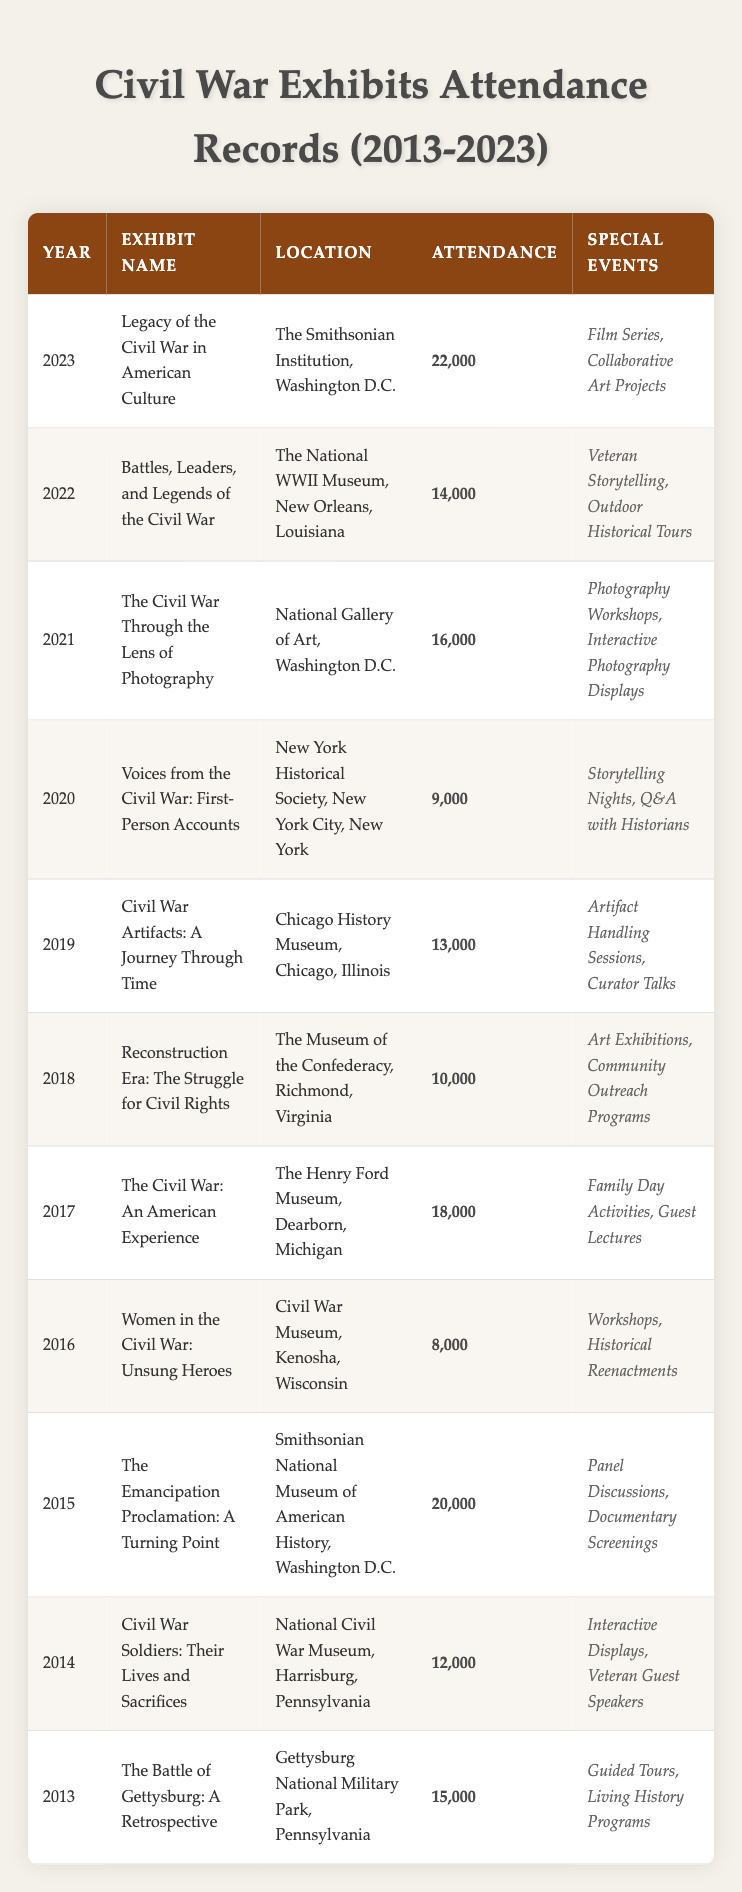What was the highest attendance recorded during the exhibits? The highest attendance can be found by looking through the attendance column in the table. The figure 22,000 in 2023 for the exhibit "Legacy of the Civil War in American Culture" is the highest.
Answer: 22,000 Which year had the minimum attendance for a Civil War exhibit? By scanning the attendance values in the table, we see that 8,000 in 2016 for the exhibit "Women in the Civil War: Unsung Heroes" is the lowest attendance recorded.
Answer: 2016 How many exhibits had an attendance of over 15,000? We can count the number of rows in the table where the attendance value exceeds 15,000. The attendance values that meet this criterion are 22,000, 20,000, 18,000, and 16,000, giving a total of four exhibits with beyond 15,000 attendance.
Answer: 4 Did the "Civil War Soldiers: Their Lives and Sacrifices" exhibit have more attendees than the "Reconstruction Era: The Struggle for Civil Rights" exhibit? The attendance for "Civil War Soldiers: Their Lives and Sacrifices" is 12,000, while for "Reconstruction Era: The Struggle for Civil Rights," it is 10,000. Since 12,000 is greater than 10,000, the statement is true.
Answer: Yes What was the total attendance for the exhibits from 2013 to 2023? To calculate the total, we need to add all attendance values: 15,000 + 12,000 + 20,000 + 8,000 + 18,000 + 10,000 + 13,000 + 9,000 + 16,000 + 14,000 + 22,000, which sums to 147,000.
Answer: 147,000 Which exhibit had the most unique special events, and how many were there? By examining the special events listed for each exhibit, we find that "The Emancipation Proclamation: A Turning Point" and "Legacy of the Civil War in American Culture" both had 2 unique events. Since they both have the maximum of 2, they tie for this distinction.
Answer: 2 In which year did the exhibit "Voices from the Civil War: First-Person Accounts" take place? The year can be directly looked up in the table under the corresponding row for "Voices from the Civil War: First-Person Accounts," which indicates it took place in 2020.
Answer: 2020 How many exhibits featured workshops as part of their special events? By inspecting each exhibit's special events, the exhibits "Women in the Civil War: Unsung Heroes" and "The Civil War Through the Lens of Photography" both had workshops listed, totaling two exhibits featuring workshops.
Answer: 2 What percentage of exhibits in 2019 had an attendance of less than 15,000? The total number of exhibits in 2019 is 11. The attendance below 15,000 exists for two exhibits ("Women in the Civil War: Unsung Heroes" and "Voices from the Civil War: First-Person Accounts"). Thus, 2 out of 11 will be (2/11) * 100 = 18.18%.
Answer: 18.18% 